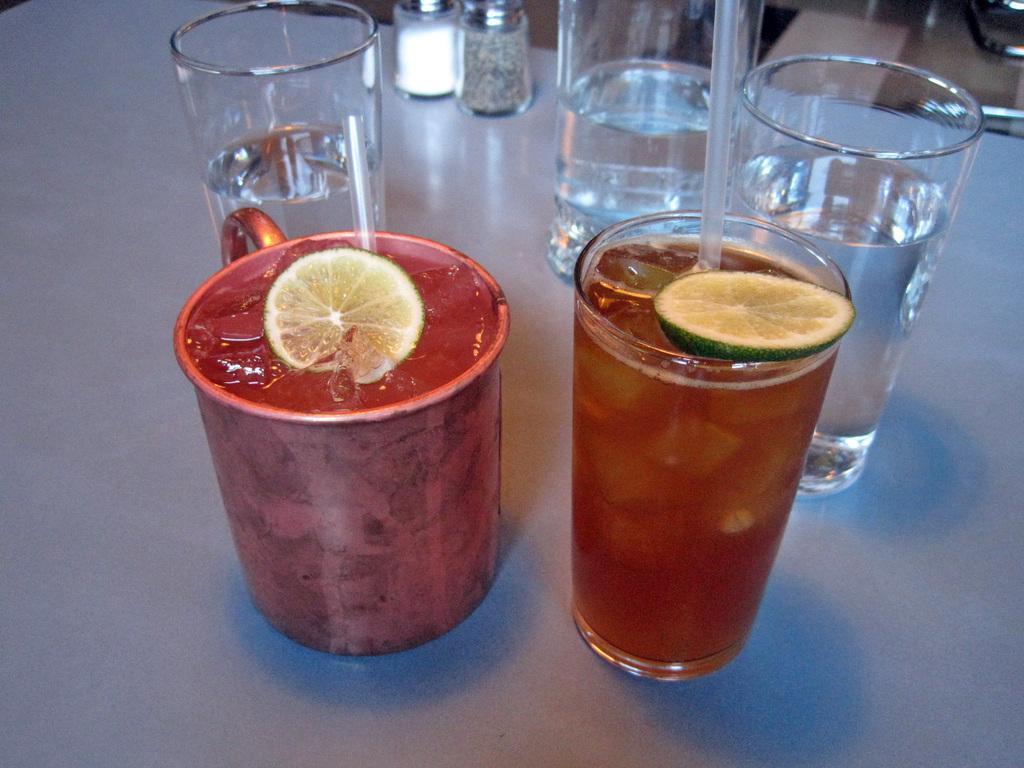Could you give a brief overview of what you see in this image? In this image I can see few glasses and the glasses are on the white color surface. I can also see the liquid in the glasses. 